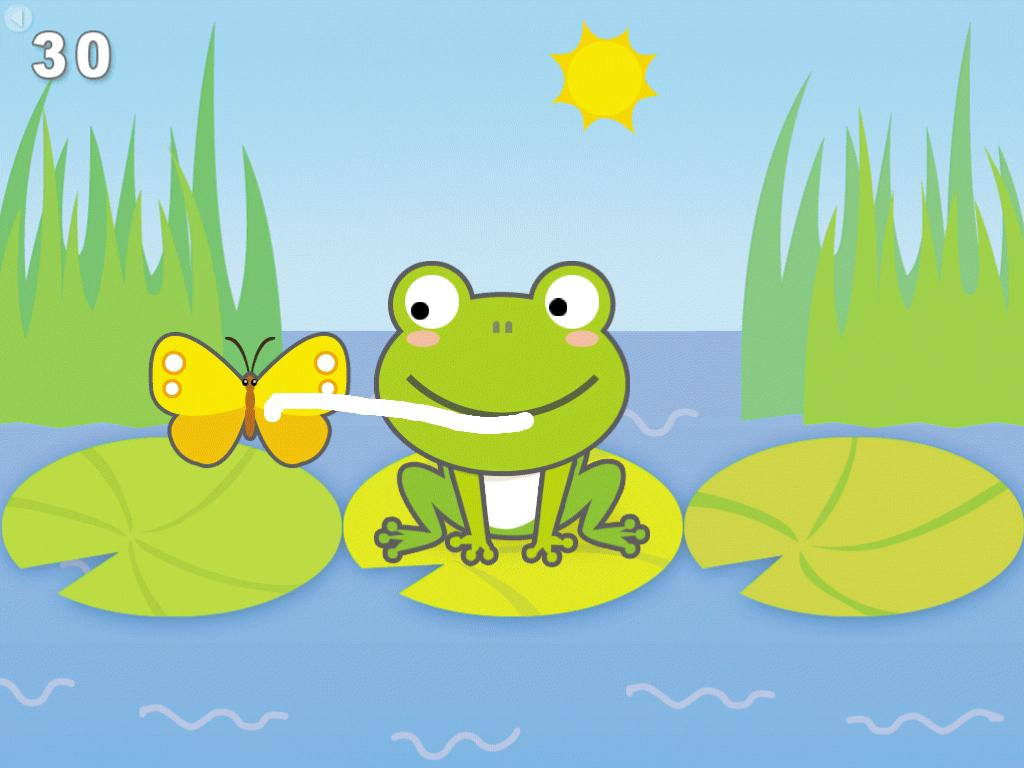What animal is the main subject of the image? There is a frog in the image. What is the frog sitting on? The frog is sitting on a green object. Where is the green object located? The green object is on water. What is the frog doing with the butterfly? The frog is holding a butterfly with its tongue. Where is the butterfly in relation to the frog? The butterfly is beside the frog. What can be seen in the background of the image? There is a sun visible in the background of the image. What type of pump can be seen in the image? There is no pump present in the image. What is the frog using to write on the pencil? The frog is not using a pencil in the image; it is holding a butterfly with its tongue. 